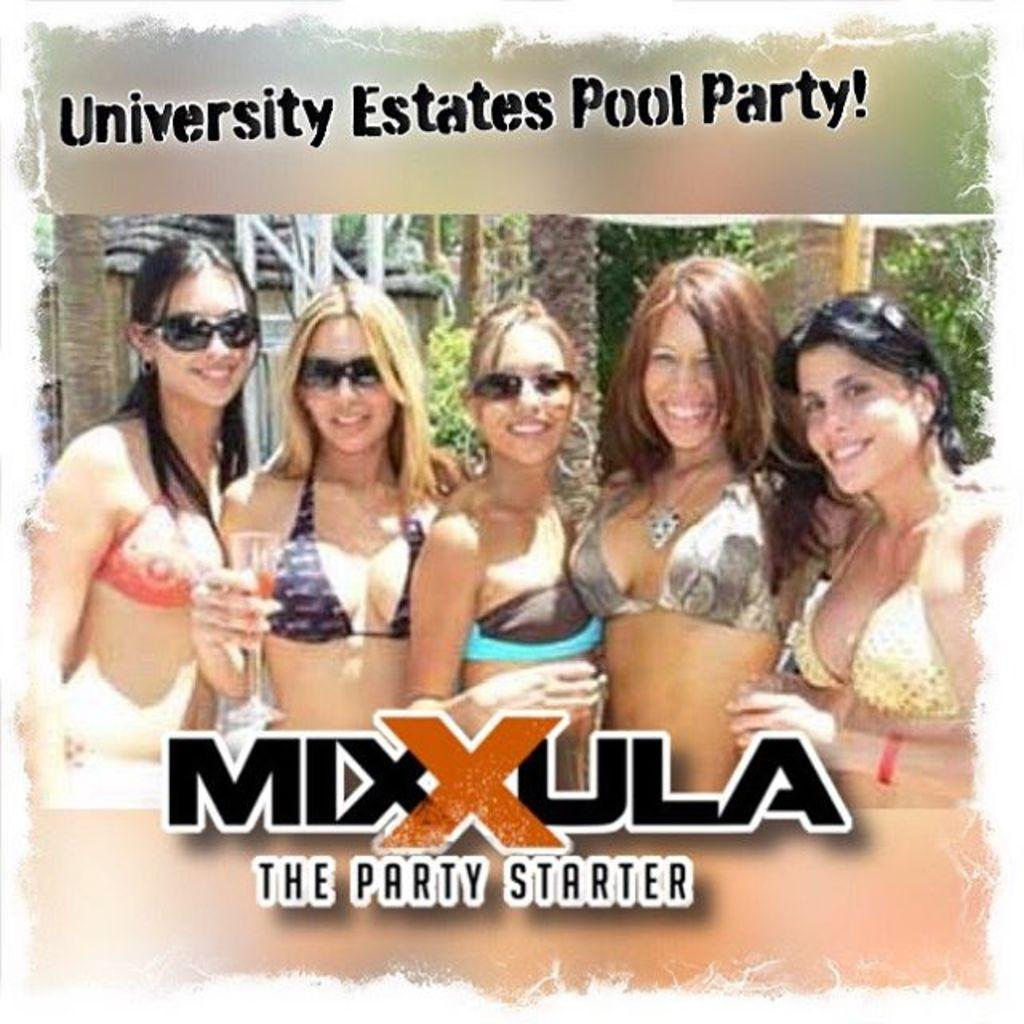What is featured in the image? There is a poster in the image. What is depicted on the poster? There are women depicted on the poster. What else is present on the poster besides the images? There is text present on the poster. Can you tell me how many ducks are drawn in the notebook shown in the image? There is no notebook present in the image, and therefore no ducks can be observed in it. 